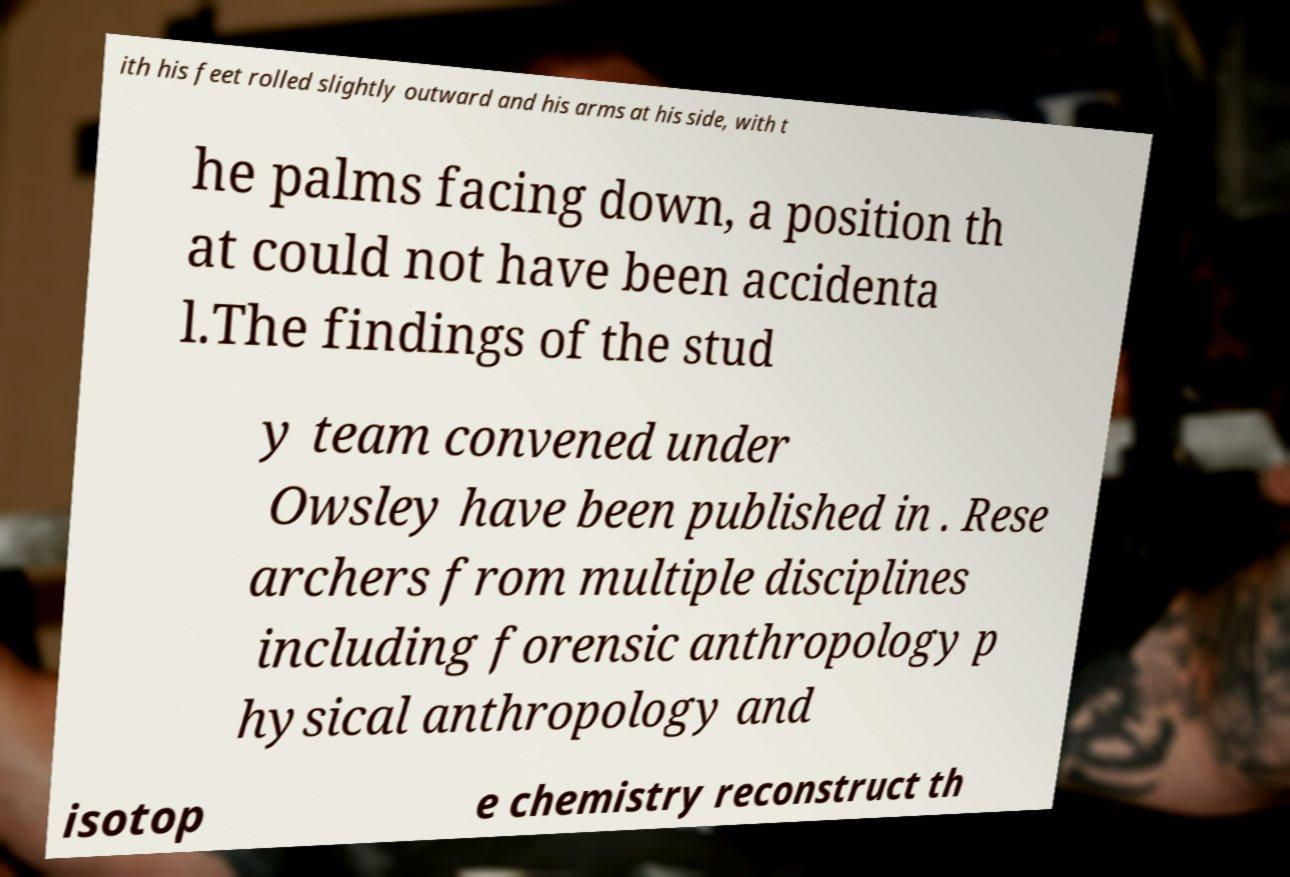Could you assist in decoding the text presented in this image and type it out clearly? ith his feet rolled slightly outward and his arms at his side, with t he palms facing down, a position th at could not have been accidenta l.The findings of the stud y team convened under Owsley have been published in . Rese archers from multiple disciplines including forensic anthropology p hysical anthropology and isotop e chemistry reconstruct th 